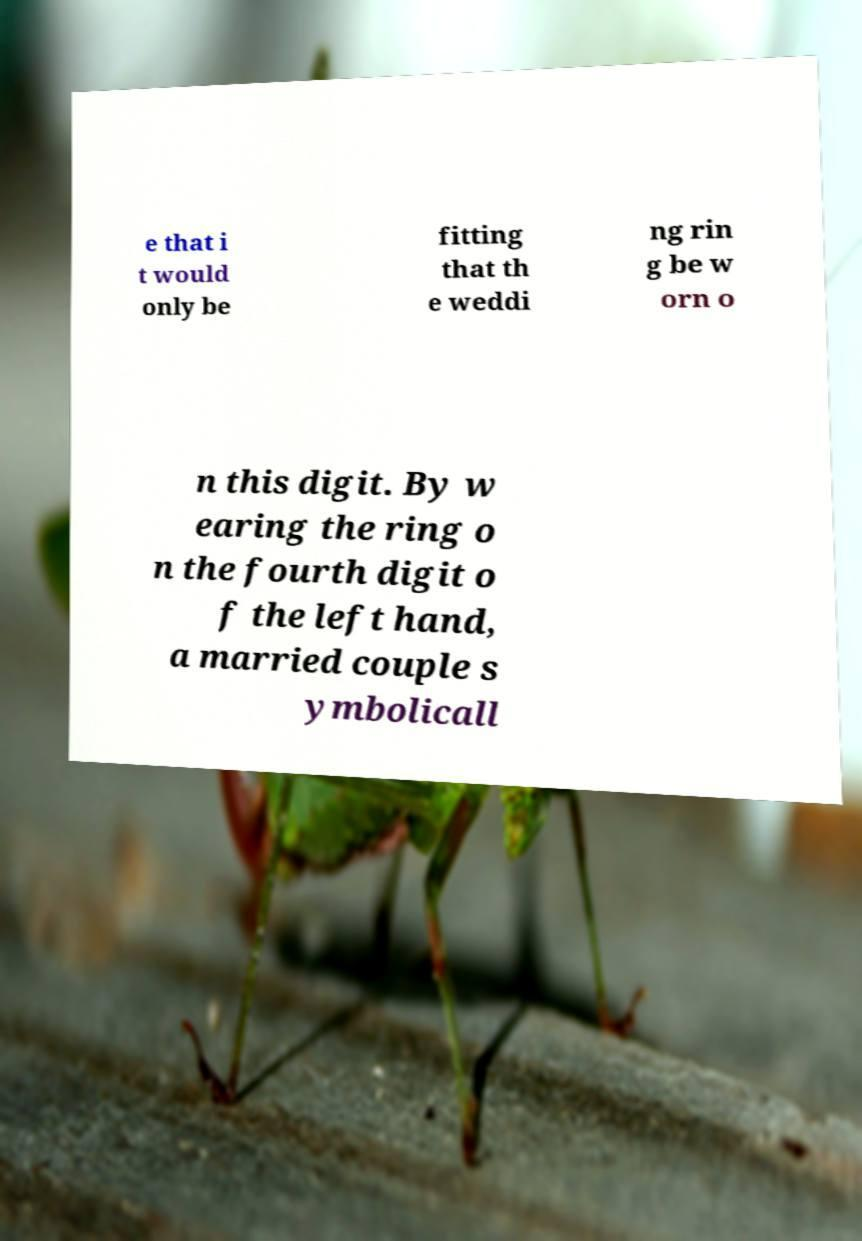Could you extract and type out the text from this image? e that i t would only be fitting that th e weddi ng rin g be w orn o n this digit. By w earing the ring o n the fourth digit o f the left hand, a married couple s ymbolicall 